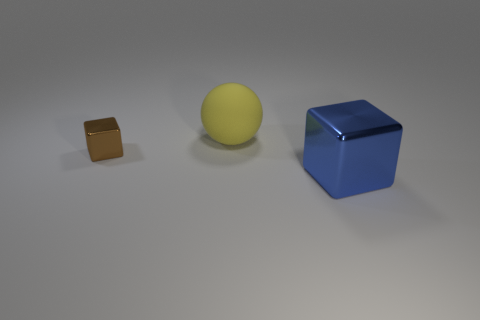Are there an equal number of small brown things that are on the right side of the large blue shiny thing and big metallic cubes?
Ensure brevity in your answer.  No. How many things are things that are in front of the brown object or large blue objects?
Give a very brief answer. 1. There is a metallic block on the right side of the small object; what size is it?
Offer a very short reply. Large. What shape is the big thing left of the cube that is right of the big rubber sphere?
Your answer should be very brief. Sphere. What color is the other thing that is the same shape as the brown thing?
Make the answer very short. Blue. There is a metal cube that is to the left of the blue cube; is it the same size as the big blue block?
Provide a succinct answer. No. How many big blue blocks have the same material as the big blue thing?
Make the answer very short. 0. The cube on the left side of the cube that is on the right side of the shiny cube on the left side of the big blue metal block is made of what material?
Provide a succinct answer. Metal. The cube that is to the left of the block to the right of the small brown object is what color?
Keep it short and to the point. Brown. There is another object that is the same size as the yellow object; what color is it?
Provide a short and direct response. Blue. 